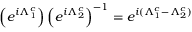<formula> <loc_0><loc_0><loc_500><loc_500>\left ( e ^ { i \Lambda _ { 1 } ^ { c } } \right ) \left ( e ^ { i \Lambda _ { 2 } ^ { c } } \right ) ^ { - 1 } = e ^ { i ( \Lambda _ { 1 } ^ { c } - \Lambda _ { 2 } ^ { c } ) }</formula> 